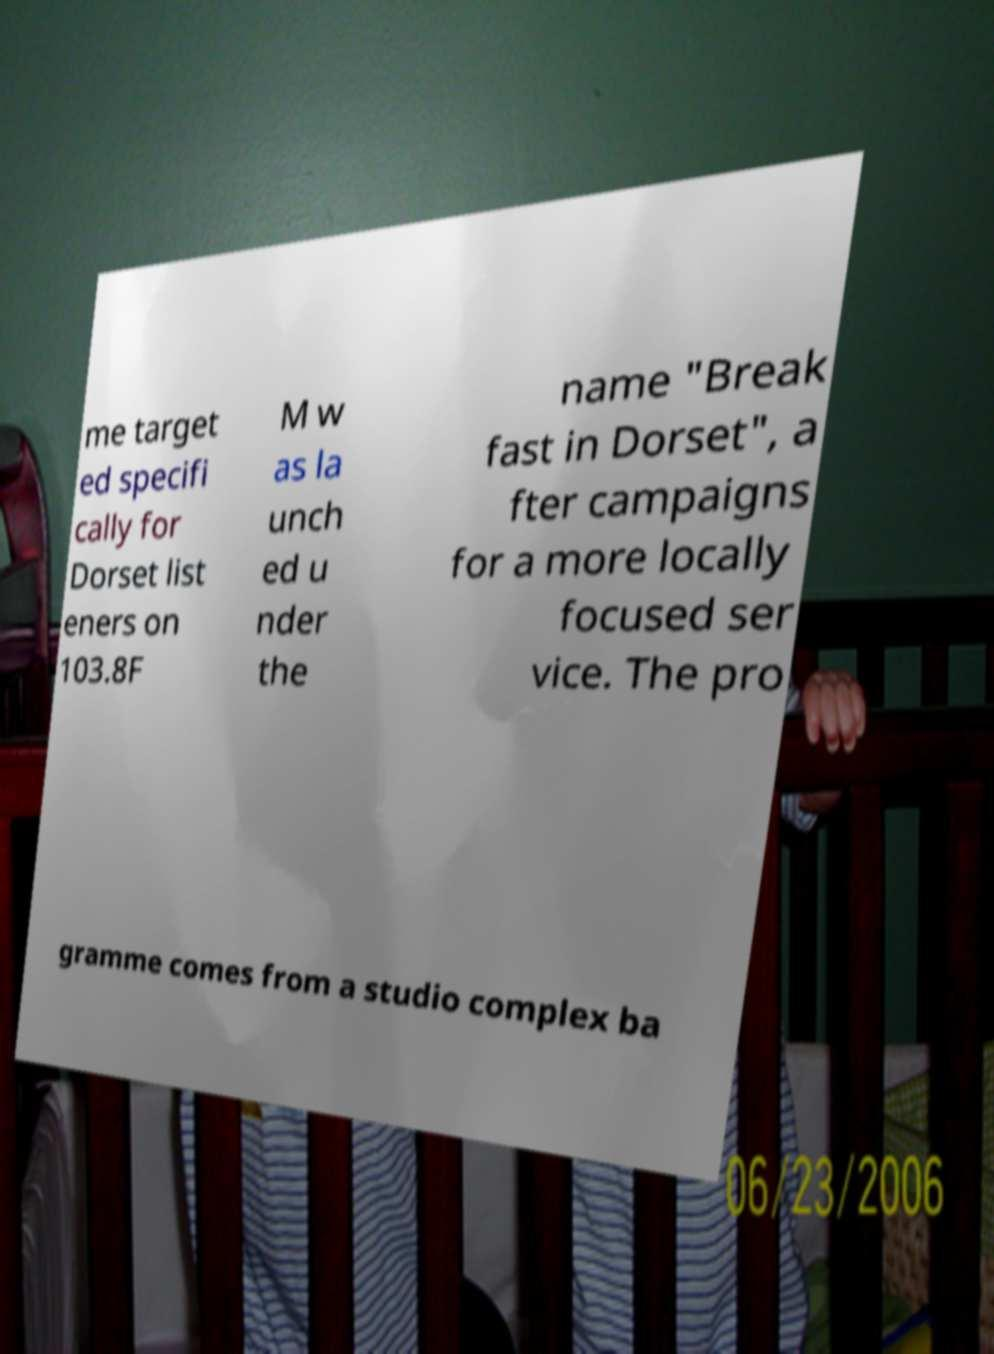Can you accurately transcribe the text from the provided image for me? me target ed specifi cally for Dorset list eners on 103.8F M w as la unch ed u nder the name "Break fast in Dorset", a fter campaigns for a more locally focused ser vice. The pro gramme comes from a studio complex ba 